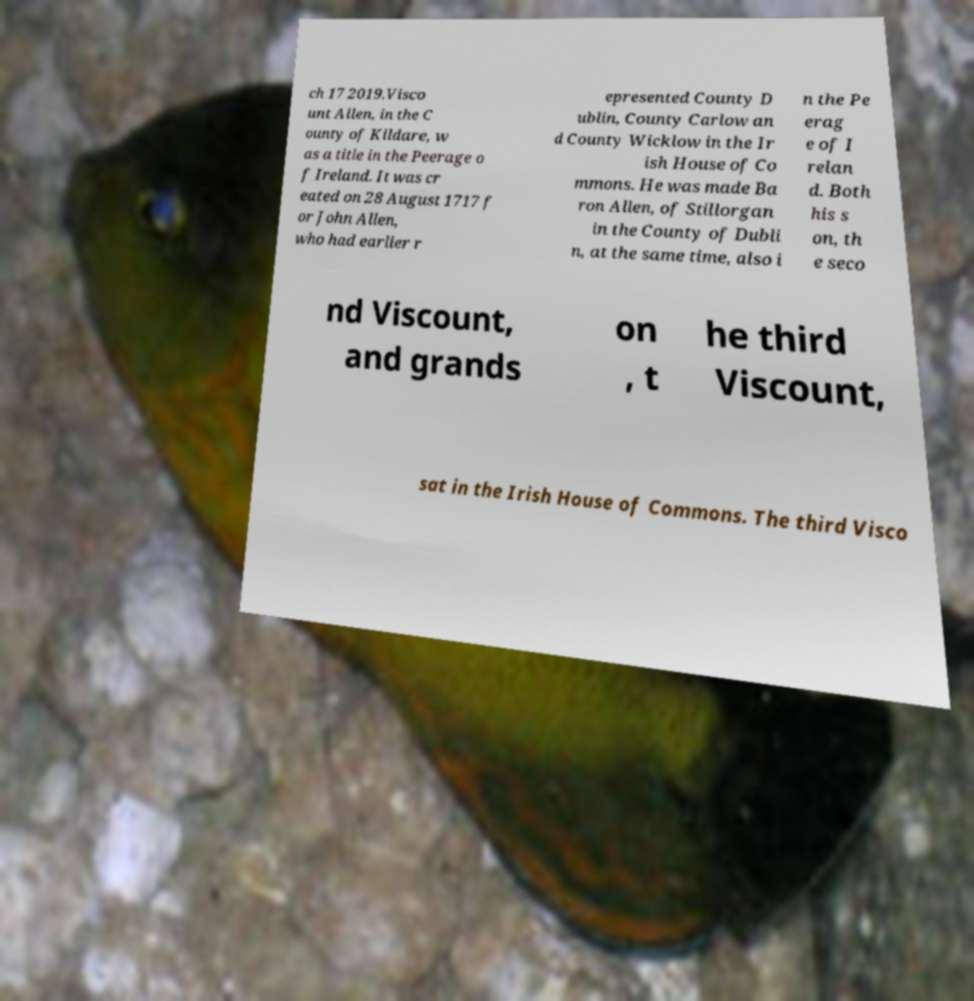Can you accurately transcribe the text from the provided image for me? ch 17 2019.Visco unt Allen, in the C ounty of Kildare, w as a title in the Peerage o f Ireland. It was cr eated on 28 August 1717 f or John Allen, who had earlier r epresented County D ublin, County Carlow an d County Wicklow in the Ir ish House of Co mmons. He was made Ba ron Allen, of Stillorgan in the County of Dubli n, at the same time, also i n the Pe erag e of I relan d. Both his s on, th e seco nd Viscount, and grands on , t he third Viscount, sat in the Irish House of Commons. The third Visco 